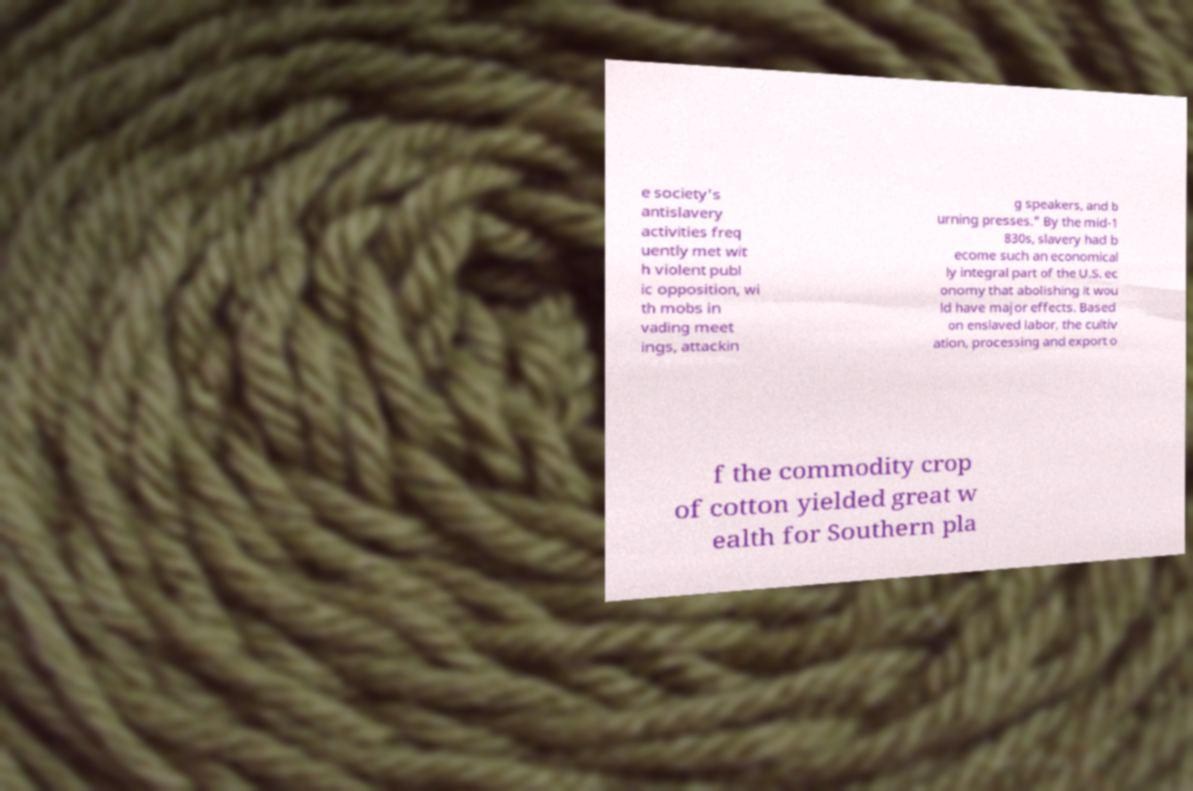I need the written content from this picture converted into text. Can you do that? e society's antislavery activities freq uently met wit h violent publ ic opposition, wi th mobs in vading meet ings, attackin g speakers, and b urning presses." By the mid-1 830s, slavery had b ecome such an economical ly integral part of the U.S. ec onomy that abolishing it wou ld have major effects. Based on enslaved labor, the cultiv ation, processing and export o f the commodity crop of cotton yielded great w ealth for Southern pla 